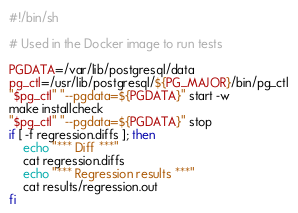Convert code to text. <code><loc_0><loc_0><loc_500><loc_500><_Bash_>#!/bin/sh

# Used in the Docker image to run tests

PGDATA=/var/lib/postgresql/data
pg_ctl=/usr/lib/postgresql/${PG_MAJOR}/bin/pg_ctl
"$pg_ctl" "--pgdata=${PGDATA}" start -w
make installcheck
"$pg_ctl" "--pgdata=${PGDATA}" stop
if [ -f regression.diffs ]; then
    echo "*** Diff ***"
    cat regression.diffs
    echo "*** Regression results ***"
    cat results/regression.out
fi
</code> 